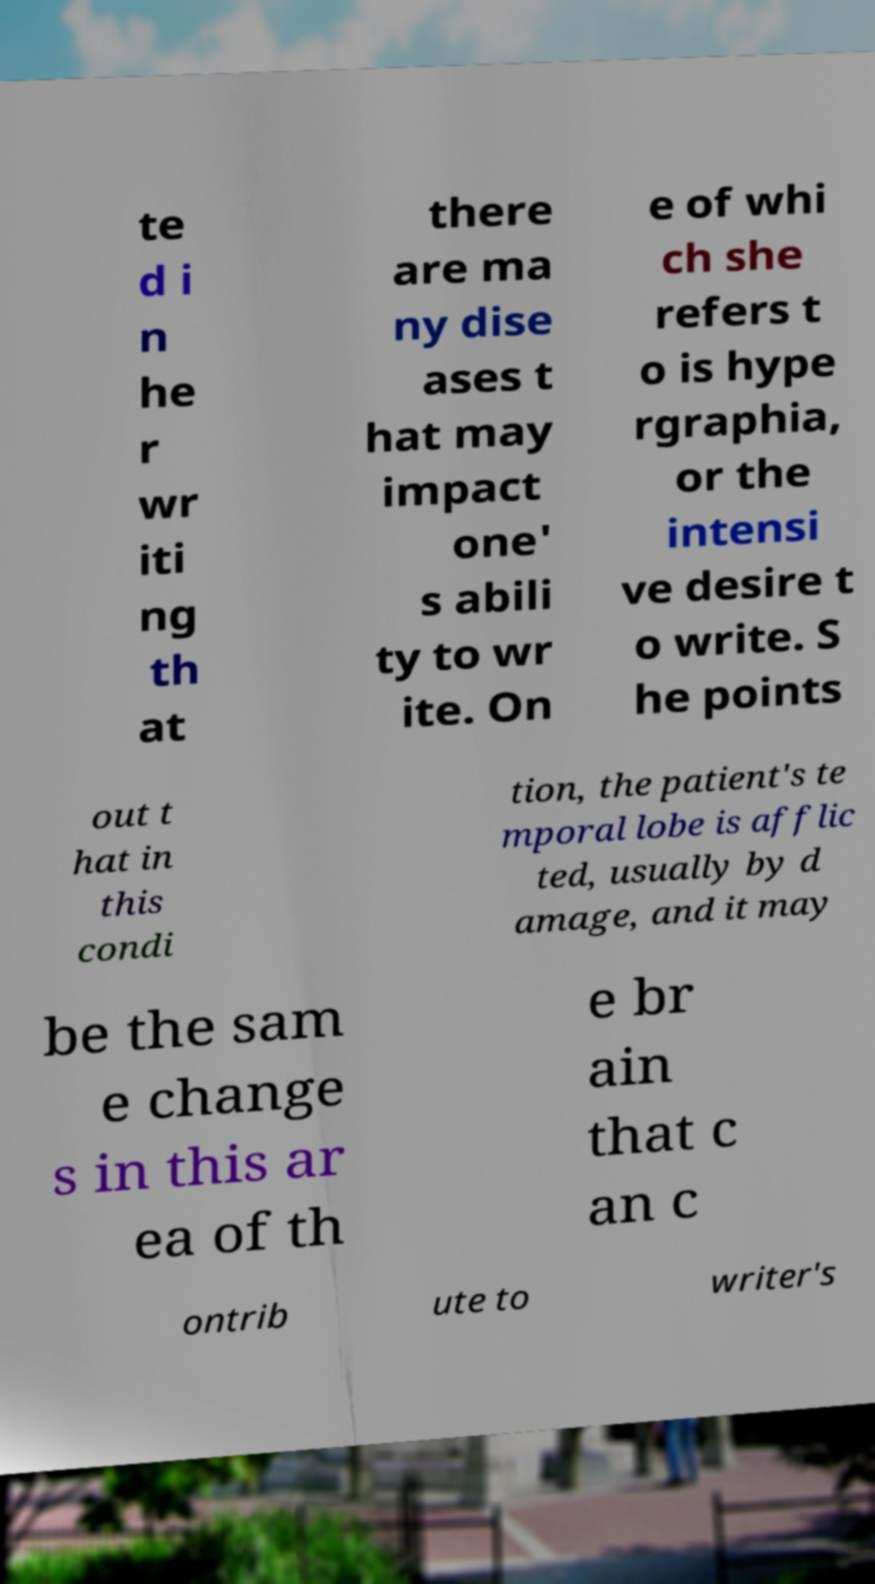Could you extract and type out the text from this image? te d i n he r wr iti ng th at there are ma ny dise ases t hat may impact one' s abili ty to wr ite. On e of whi ch she refers t o is hype rgraphia, or the intensi ve desire t o write. S he points out t hat in this condi tion, the patient's te mporal lobe is afflic ted, usually by d amage, and it may be the sam e change s in this ar ea of th e br ain that c an c ontrib ute to writer's 